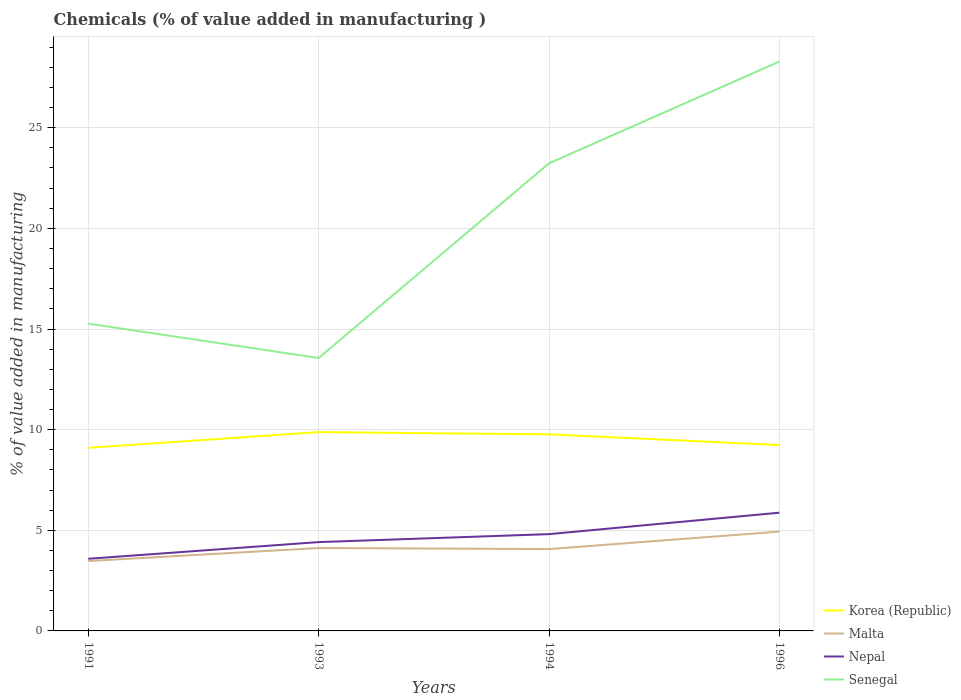How many different coloured lines are there?
Offer a terse response. 4. Does the line corresponding to Korea (Republic) intersect with the line corresponding to Nepal?
Provide a short and direct response. No. Across all years, what is the maximum value added in manufacturing chemicals in Nepal?
Offer a terse response. 3.58. In which year was the value added in manufacturing chemicals in Senegal maximum?
Your answer should be compact. 1993. What is the total value added in manufacturing chemicals in Malta in the graph?
Offer a terse response. -0.87. What is the difference between the highest and the second highest value added in manufacturing chemicals in Malta?
Keep it short and to the point. 1.46. Is the value added in manufacturing chemicals in Nepal strictly greater than the value added in manufacturing chemicals in Korea (Republic) over the years?
Your response must be concise. Yes. How many lines are there?
Make the answer very short. 4. How many years are there in the graph?
Offer a terse response. 4. What is the difference between two consecutive major ticks on the Y-axis?
Keep it short and to the point. 5. Does the graph contain grids?
Give a very brief answer. Yes. How are the legend labels stacked?
Your response must be concise. Vertical. What is the title of the graph?
Your answer should be very brief. Chemicals (% of value added in manufacturing ). Does "Low income" appear as one of the legend labels in the graph?
Your answer should be compact. No. What is the label or title of the Y-axis?
Keep it short and to the point. % of value added in manufacturing. What is the % of value added in manufacturing of Korea (Republic) in 1991?
Make the answer very short. 9.1. What is the % of value added in manufacturing of Malta in 1991?
Make the answer very short. 3.47. What is the % of value added in manufacturing in Nepal in 1991?
Offer a very short reply. 3.58. What is the % of value added in manufacturing of Senegal in 1991?
Your response must be concise. 15.27. What is the % of value added in manufacturing of Korea (Republic) in 1993?
Offer a very short reply. 9.88. What is the % of value added in manufacturing of Malta in 1993?
Provide a short and direct response. 4.12. What is the % of value added in manufacturing of Nepal in 1993?
Offer a very short reply. 4.41. What is the % of value added in manufacturing in Senegal in 1993?
Keep it short and to the point. 13.56. What is the % of value added in manufacturing of Korea (Republic) in 1994?
Provide a succinct answer. 9.77. What is the % of value added in manufacturing in Malta in 1994?
Provide a short and direct response. 4.07. What is the % of value added in manufacturing of Nepal in 1994?
Offer a terse response. 4.81. What is the % of value added in manufacturing of Senegal in 1994?
Make the answer very short. 23.23. What is the % of value added in manufacturing of Korea (Republic) in 1996?
Ensure brevity in your answer.  9.24. What is the % of value added in manufacturing in Malta in 1996?
Ensure brevity in your answer.  4.93. What is the % of value added in manufacturing in Nepal in 1996?
Your answer should be very brief. 5.87. What is the % of value added in manufacturing of Senegal in 1996?
Give a very brief answer. 28.29. Across all years, what is the maximum % of value added in manufacturing in Korea (Republic)?
Provide a short and direct response. 9.88. Across all years, what is the maximum % of value added in manufacturing in Malta?
Offer a very short reply. 4.93. Across all years, what is the maximum % of value added in manufacturing in Nepal?
Make the answer very short. 5.87. Across all years, what is the maximum % of value added in manufacturing in Senegal?
Your answer should be very brief. 28.29. Across all years, what is the minimum % of value added in manufacturing of Korea (Republic)?
Your answer should be compact. 9.1. Across all years, what is the minimum % of value added in manufacturing in Malta?
Offer a terse response. 3.47. Across all years, what is the minimum % of value added in manufacturing of Nepal?
Your response must be concise. 3.58. Across all years, what is the minimum % of value added in manufacturing in Senegal?
Provide a succinct answer. 13.56. What is the total % of value added in manufacturing of Korea (Republic) in the graph?
Your answer should be compact. 37.98. What is the total % of value added in manufacturing of Malta in the graph?
Make the answer very short. 16.59. What is the total % of value added in manufacturing of Nepal in the graph?
Make the answer very short. 18.68. What is the total % of value added in manufacturing of Senegal in the graph?
Provide a succinct answer. 80.34. What is the difference between the % of value added in manufacturing of Korea (Republic) in 1991 and that in 1993?
Provide a succinct answer. -0.78. What is the difference between the % of value added in manufacturing of Malta in 1991 and that in 1993?
Ensure brevity in your answer.  -0.65. What is the difference between the % of value added in manufacturing of Nepal in 1991 and that in 1993?
Your answer should be very brief. -0.83. What is the difference between the % of value added in manufacturing of Senegal in 1991 and that in 1993?
Your answer should be compact. 1.71. What is the difference between the % of value added in manufacturing in Korea (Republic) in 1991 and that in 1994?
Provide a short and direct response. -0.67. What is the difference between the % of value added in manufacturing in Malta in 1991 and that in 1994?
Your answer should be very brief. -0.59. What is the difference between the % of value added in manufacturing in Nepal in 1991 and that in 1994?
Offer a terse response. -1.22. What is the difference between the % of value added in manufacturing in Senegal in 1991 and that in 1994?
Your answer should be compact. -7.97. What is the difference between the % of value added in manufacturing of Korea (Republic) in 1991 and that in 1996?
Offer a terse response. -0.14. What is the difference between the % of value added in manufacturing in Malta in 1991 and that in 1996?
Make the answer very short. -1.46. What is the difference between the % of value added in manufacturing in Nepal in 1991 and that in 1996?
Provide a succinct answer. -2.29. What is the difference between the % of value added in manufacturing in Senegal in 1991 and that in 1996?
Keep it short and to the point. -13.02. What is the difference between the % of value added in manufacturing in Korea (Republic) in 1993 and that in 1994?
Offer a very short reply. 0.11. What is the difference between the % of value added in manufacturing of Malta in 1993 and that in 1994?
Keep it short and to the point. 0.05. What is the difference between the % of value added in manufacturing in Nepal in 1993 and that in 1994?
Give a very brief answer. -0.4. What is the difference between the % of value added in manufacturing in Senegal in 1993 and that in 1994?
Keep it short and to the point. -9.67. What is the difference between the % of value added in manufacturing in Korea (Republic) in 1993 and that in 1996?
Provide a short and direct response. 0.64. What is the difference between the % of value added in manufacturing in Malta in 1993 and that in 1996?
Your response must be concise. -0.82. What is the difference between the % of value added in manufacturing of Nepal in 1993 and that in 1996?
Keep it short and to the point. -1.46. What is the difference between the % of value added in manufacturing of Senegal in 1993 and that in 1996?
Give a very brief answer. -14.73. What is the difference between the % of value added in manufacturing of Korea (Republic) in 1994 and that in 1996?
Keep it short and to the point. 0.53. What is the difference between the % of value added in manufacturing of Malta in 1994 and that in 1996?
Make the answer very short. -0.87. What is the difference between the % of value added in manufacturing of Nepal in 1994 and that in 1996?
Your answer should be very brief. -1.07. What is the difference between the % of value added in manufacturing of Senegal in 1994 and that in 1996?
Provide a succinct answer. -5.06. What is the difference between the % of value added in manufacturing in Korea (Republic) in 1991 and the % of value added in manufacturing in Malta in 1993?
Keep it short and to the point. 4.98. What is the difference between the % of value added in manufacturing in Korea (Republic) in 1991 and the % of value added in manufacturing in Nepal in 1993?
Keep it short and to the point. 4.68. What is the difference between the % of value added in manufacturing of Korea (Republic) in 1991 and the % of value added in manufacturing of Senegal in 1993?
Make the answer very short. -4.46. What is the difference between the % of value added in manufacturing in Malta in 1991 and the % of value added in manufacturing in Nepal in 1993?
Your response must be concise. -0.94. What is the difference between the % of value added in manufacturing of Malta in 1991 and the % of value added in manufacturing of Senegal in 1993?
Your response must be concise. -10.09. What is the difference between the % of value added in manufacturing in Nepal in 1991 and the % of value added in manufacturing in Senegal in 1993?
Provide a succinct answer. -9.97. What is the difference between the % of value added in manufacturing of Korea (Republic) in 1991 and the % of value added in manufacturing of Malta in 1994?
Give a very brief answer. 5.03. What is the difference between the % of value added in manufacturing of Korea (Republic) in 1991 and the % of value added in manufacturing of Nepal in 1994?
Offer a very short reply. 4.29. What is the difference between the % of value added in manufacturing in Korea (Republic) in 1991 and the % of value added in manufacturing in Senegal in 1994?
Offer a very short reply. -14.14. What is the difference between the % of value added in manufacturing in Malta in 1991 and the % of value added in manufacturing in Nepal in 1994?
Ensure brevity in your answer.  -1.34. What is the difference between the % of value added in manufacturing in Malta in 1991 and the % of value added in manufacturing in Senegal in 1994?
Keep it short and to the point. -19.76. What is the difference between the % of value added in manufacturing of Nepal in 1991 and the % of value added in manufacturing of Senegal in 1994?
Your answer should be compact. -19.65. What is the difference between the % of value added in manufacturing in Korea (Republic) in 1991 and the % of value added in manufacturing in Malta in 1996?
Make the answer very short. 4.16. What is the difference between the % of value added in manufacturing in Korea (Republic) in 1991 and the % of value added in manufacturing in Nepal in 1996?
Your response must be concise. 3.22. What is the difference between the % of value added in manufacturing of Korea (Republic) in 1991 and the % of value added in manufacturing of Senegal in 1996?
Provide a succinct answer. -19.19. What is the difference between the % of value added in manufacturing of Malta in 1991 and the % of value added in manufacturing of Nepal in 1996?
Your answer should be compact. -2.4. What is the difference between the % of value added in manufacturing in Malta in 1991 and the % of value added in manufacturing in Senegal in 1996?
Your answer should be very brief. -24.82. What is the difference between the % of value added in manufacturing in Nepal in 1991 and the % of value added in manufacturing in Senegal in 1996?
Make the answer very short. -24.7. What is the difference between the % of value added in manufacturing in Korea (Republic) in 1993 and the % of value added in manufacturing in Malta in 1994?
Your response must be concise. 5.81. What is the difference between the % of value added in manufacturing in Korea (Republic) in 1993 and the % of value added in manufacturing in Nepal in 1994?
Your answer should be very brief. 5.07. What is the difference between the % of value added in manufacturing in Korea (Republic) in 1993 and the % of value added in manufacturing in Senegal in 1994?
Make the answer very short. -13.35. What is the difference between the % of value added in manufacturing in Malta in 1993 and the % of value added in manufacturing in Nepal in 1994?
Your response must be concise. -0.69. What is the difference between the % of value added in manufacturing in Malta in 1993 and the % of value added in manufacturing in Senegal in 1994?
Keep it short and to the point. -19.11. What is the difference between the % of value added in manufacturing of Nepal in 1993 and the % of value added in manufacturing of Senegal in 1994?
Offer a terse response. -18.82. What is the difference between the % of value added in manufacturing of Korea (Republic) in 1993 and the % of value added in manufacturing of Malta in 1996?
Your answer should be very brief. 4.94. What is the difference between the % of value added in manufacturing in Korea (Republic) in 1993 and the % of value added in manufacturing in Nepal in 1996?
Your answer should be very brief. 4. What is the difference between the % of value added in manufacturing in Korea (Republic) in 1993 and the % of value added in manufacturing in Senegal in 1996?
Provide a succinct answer. -18.41. What is the difference between the % of value added in manufacturing in Malta in 1993 and the % of value added in manufacturing in Nepal in 1996?
Offer a very short reply. -1.76. What is the difference between the % of value added in manufacturing in Malta in 1993 and the % of value added in manufacturing in Senegal in 1996?
Your answer should be compact. -24.17. What is the difference between the % of value added in manufacturing in Nepal in 1993 and the % of value added in manufacturing in Senegal in 1996?
Make the answer very short. -23.87. What is the difference between the % of value added in manufacturing of Korea (Republic) in 1994 and the % of value added in manufacturing of Malta in 1996?
Ensure brevity in your answer.  4.83. What is the difference between the % of value added in manufacturing of Korea (Republic) in 1994 and the % of value added in manufacturing of Nepal in 1996?
Provide a succinct answer. 3.89. What is the difference between the % of value added in manufacturing of Korea (Republic) in 1994 and the % of value added in manufacturing of Senegal in 1996?
Offer a very short reply. -18.52. What is the difference between the % of value added in manufacturing in Malta in 1994 and the % of value added in manufacturing in Nepal in 1996?
Provide a short and direct response. -1.81. What is the difference between the % of value added in manufacturing in Malta in 1994 and the % of value added in manufacturing in Senegal in 1996?
Make the answer very short. -24.22. What is the difference between the % of value added in manufacturing in Nepal in 1994 and the % of value added in manufacturing in Senegal in 1996?
Offer a terse response. -23.48. What is the average % of value added in manufacturing in Korea (Republic) per year?
Make the answer very short. 9.49. What is the average % of value added in manufacturing of Malta per year?
Give a very brief answer. 4.15. What is the average % of value added in manufacturing in Nepal per year?
Your answer should be compact. 4.67. What is the average % of value added in manufacturing in Senegal per year?
Give a very brief answer. 20.09. In the year 1991, what is the difference between the % of value added in manufacturing in Korea (Republic) and % of value added in manufacturing in Malta?
Provide a succinct answer. 5.62. In the year 1991, what is the difference between the % of value added in manufacturing in Korea (Republic) and % of value added in manufacturing in Nepal?
Ensure brevity in your answer.  5.51. In the year 1991, what is the difference between the % of value added in manufacturing of Korea (Republic) and % of value added in manufacturing of Senegal?
Make the answer very short. -6.17. In the year 1991, what is the difference between the % of value added in manufacturing in Malta and % of value added in manufacturing in Nepal?
Make the answer very short. -0.11. In the year 1991, what is the difference between the % of value added in manufacturing in Malta and % of value added in manufacturing in Senegal?
Ensure brevity in your answer.  -11.8. In the year 1991, what is the difference between the % of value added in manufacturing of Nepal and % of value added in manufacturing of Senegal?
Keep it short and to the point. -11.68. In the year 1993, what is the difference between the % of value added in manufacturing in Korea (Republic) and % of value added in manufacturing in Malta?
Your answer should be very brief. 5.76. In the year 1993, what is the difference between the % of value added in manufacturing of Korea (Republic) and % of value added in manufacturing of Nepal?
Your answer should be compact. 5.46. In the year 1993, what is the difference between the % of value added in manufacturing of Korea (Republic) and % of value added in manufacturing of Senegal?
Your response must be concise. -3.68. In the year 1993, what is the difference between the % of value added in manufacturing of Malta and % of value added in manufacturing of Nepal?
Make the answer very short. -0.29. In the year 1993, what is the difference between the % of value added in manufacturing in Malta and % of value added in manufacturing in Senegal?
Your answer should be very brief. -9.44. In the year 1993, what is the difference between the % of value added in manufacturing in Nepal and % of value added in manufacturing in Senegal?
Your response must be concise. -9.15. In the year 1994, what is the difference between the % of value added in manufacturing of Korea (Republic) and % of value added in manufacturing of Malta?
Give a very brief answer. 5.7. In the year 1994, what is the difference between the % of value added in manufacturing of Korea (Republic) and % of value added in manufacturing of Nepal?
Your answer should be very brief. 4.96. In the year 1994, what is the difference between the % of value added in manufacturing of Korea (Republic) and % of value added in manufacturing of Senegal?
Ensure brevity in your answer.  -13.47. In the year 1994, what is the difference between the % of value added in manufacturing of Malta and % of value added in manufacturing of Nepal?
Provide a succinct answer. -0.74. In the year 1994, what is the difference between the % of value added in manufacturing of Malta and % of value added in manufacturing of Senegal?
Your answer should be compact. -19.17. In the year 1994, what is the difference between the % of value added in manufacturing in Nepal and % of value added in manufacturing in Senegal?
Your response must be concise. -18.42. In the year 1996, what is the difference between the % of value added in manufacturing of Korea (Republic) and % of value added in manufacturing of Malta?
Your response must be concise. 4.3. In the year 1996, what is the difference between the % of value added in manufacturing in Korea (Republic) and % of value added in manufacturing in Nepal?
Offer a very short reply. 3.36. In the year 1996, what is the difference between the % of value added in manufacturing in Korea (Republic) and % of value added in manufacturing in Senegal?
Offer a very short reply. -19.05. In the year 1996, what is the difference between the % of value added in manufacturing of Malta and % of value added in manufacturing of Nepal?
Your response must be concise. -0.94. In the year 1996, what is the difference between the % of value added in manufacturing in Malta and % of value added in manufacturing in Senegal?
Provide a short and direct response. -23.35. In the year 1996, what is the difference between the % of value added in manufacturing in Nepal and % of value added in manufacturing in Senegal?
Give a very brief answer. -22.41. What is the ratio of the % of value added in manufacturing of Korea (Republic) in 1991 to that in 1993?
Your answer should be compact. 0.92. What is the ratio of the % of value added in manufacturing in Malta in 1991 to that in 1993?
Your answer should be compact. 0.84. What is the ratio of the % of value added in manufacturing in Nepal in 1991 to that in 1993?
Make the answer very short. 0.81. What is the ratio of the % of value added in manufacturing in Senegal in 1991 to that in 1993?
Give a very brief answer. 1.13. What is the ratio of the % of value added in manufacturing of Korea (Republic) in 1991 to that in 1994?
Keep it short and to the point. 0.93. What is the ratio of the % of value added in manufacturing of Malta in 1991 to that in 1994?
Make the answer very short. 0.85. What is the ratio of the % of value added in manufacturing in Nepal in 1991 to that in 1994?
Ensure brevity in your answer.  0.75. What is the ratio of the % of value added in manufacturing in Senegal in 1991 to that in 1994?
Your answer should be very brief. 0.66. What is the ratio of the % of value added in manufacturing of Korea (Republic) in 1991 to that in 1996?
Offer a terse response. 0.98. What is the ratio of the % of value added in manufacturing of Malta in 1991 to that in 1996?
Offer a very short reply. 0.7. What is the ratio of the % of value added in manufacturing in Nepal in 1991 to that in 1996?
Ensure brevity in your answer.  0.61. What is the ratio of the % of value added in manufacturing in Senegal in 1991 to that in 1996?
Ensure brevity in your answer.  0.54. What is the ratio of the % of value added in manufacturing of Korea (Republic) in 1993 to that in 1994?
Offer a terse response. 1.01. What is the ratio of the % of value added in manufacturing in Malta in 1993 to that in 1994?
Offer a terse response. 1.01. What is the ratio of the % of value added in manufacturing of Nepal in 1993 to that in 1994?
Make the answer very short. 0.92. What is the ratio of the % of value added in manufacturing in Senegal in 1993 to that in 1994?
Provide a succinct answer. 0.58. What is the ratio of the % of value added in manufacturing of Korea (Republic) in 1993 to that in 1996?
Ensure brevity in your answer.  1.07. What is the ratio of the % of value added in manufacturing in Malta in 1993 to that in 1996?
Offer a very short reply. 0.83. What is the ratio of the % of value added in manufacturing of Nepal in 1993 to that in 1996?
Ensure brevity in your answer.  0.75. What is the ratio of the % of value added in manufacturing in Senegal in 1993 to that in 1996?
Keep it short and to the point. 0.48. What is the ratio of the % of value added in manufacturing of Korea (Republic) in 1994 to that in 1996?
Provide a succinct answer. 1.06. What is the ratio of the % of value added in manufacturing in Malta in 1994 to that in 1996?
Offer a very short reply. 0.82. What is the ratio of the % of value added in manufacturing of Nepal in 1994 to that in 1996?
Your answer should be compact. 0.82. What is the ratio of the % of value added in manufacturing of Senegal in 1994 to that in 1996?
Offer a terse response. 0.82. What is the difference between the highest and the second highest % of value added in manufacturing in Korea (Republic)?
Make the answer very short. 0.11. What is the difference between the highest and the second highest % of value added in manufacturing in Malta?
Provide a succinct answer. 0.82. What is the difference between the highest and the second highest % of value added in manufacturing of Nepal?
Provide a succinct answer. 1.07. What is the difference between the highest and the second highest % of value added in manufacturing of Senegal?
Your answer should be very brief. 5.06. What is the difference between the highest and the lowest % of value added in manufacturing of Korea (Republic)?
Your answer should be compact. 0.78. What is the difference between the highest and the lowest % of value added in manufacturing in Malta?
Keep it short and to the point. 1.46. What is the difference between the highest and the lowest % of value added in manufacturing in Nepal?
Make the answer very short. 2.29. What is the difference between the highest and the lowest % of value added in manufacturing in Senegal?
Your response must be concise. 14.73. 